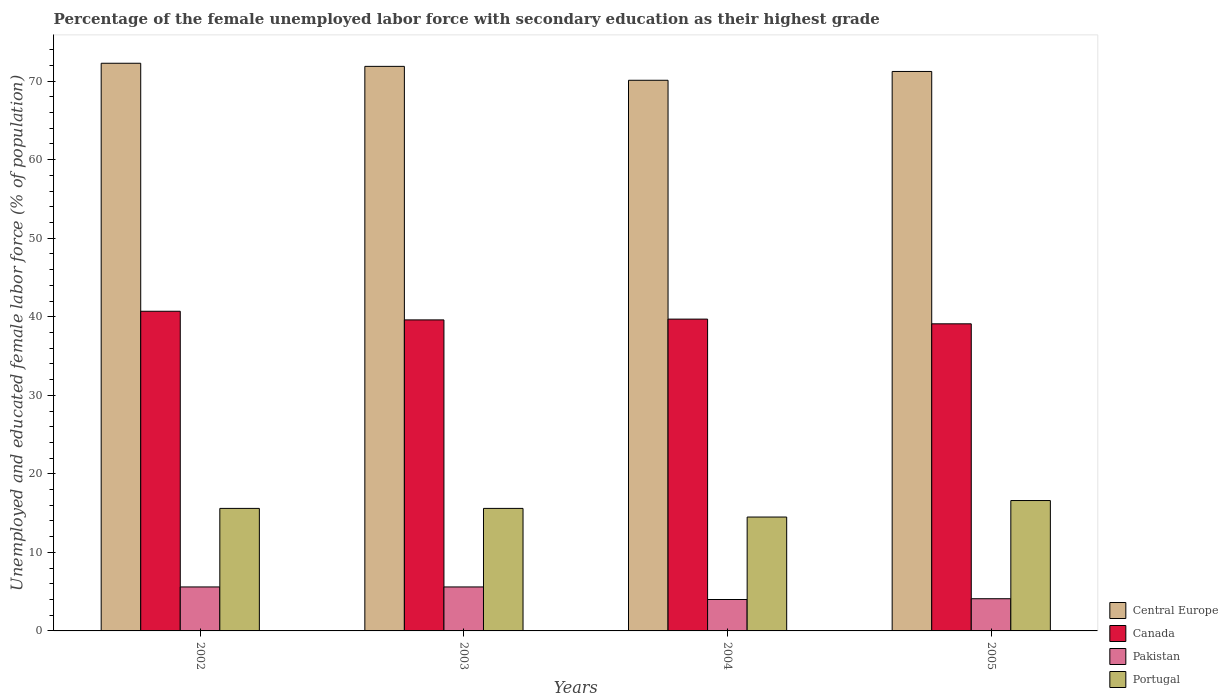How many groups of bars are there?
Make the answer very short. 4. Are the number of bars on each tick of the X-axis equal?
Offer a terse response. Yes. How many bars are there on the 1st tick from the left?
Give a very brief answer. 4. What is the label of the 3rd group of bars from the left?
Keep it short and to the point. 2004. What is the percentage of the unemployed female labor force with secondary education in Canada in 2005?
Ensure brevity in your answer.  39.1. Across all years, what is the maximum percentage of the unemployed female labor force with secondary education in Portugal?
Offer a terse response. 16.6. What is the total percentage of the unemployed female labor force with secondary education in Central Europe in the graph?
Provide a short and direct response. 285.49. What is the difference between the percentage of the unemployed female labor force with secondary education in Canada in 2003 and that in 2004?
Ensure brevity in your answer.  -0.1. What is the difference between the percentage of the unemployed female labor force with secondary education in Canada in 2005 and the percentage of the unemployed female labor force with secondary education in Central Europe in 2004?
Give a very brief answer. -31.01. What is the average percentage of the unemployed female labor force with secondary education in Portugal per year?
Provide a short and direct response. 15.58. In the year 2005, what is the difference between the percentage of the unemployed female labor force with secondary education in Central Europe and percentage of the unemployed female labor force with secondary education in Pakistan?
Give a very brief answer. 67.13. What is the ratio of the percentage of the unemployed female labor force with secondary education in Portugal in 2002 to that in 2005?
Keep it short and to the point. 0.94. What is the difference between the highest and the lowest percentage of the unemployed female labor force with secondary education in Central Europe?
Provide a short and direct response. 2.17. In how many years, is the percentage of the unemployed female labor force with secondary education in Pakistan greater than the average percentage of the unemployed female labor force with secondary education in Pakistan taken over all years?
Your response must be concise. 2. Is the sum of the percentage of the unemployed female labor force with secondary education in Canada in 2003 and 2005 greater than the maximum percentage of the unemployed female labor force with secondary education in Central Europe across all years?
Ensure brevity in your answer.  Yes. Is it the case that in every year, the sum of the percentage of the unemployed female labor force with secondary education in Canada and percentage of the unemployed female labor force with secondary education in Portugal is greater than the sum of percentage of the unemployed female labor force with secondary education in Pakistan and percentage of the unemployed female labor force with secondary education in Central Europe?
Ensure brevity in your answer.  Yes. What does the 1st bar from the left in 2005 represents?
Give a very brief answer. Central Europe. Is it the case that in every year, the sum of the percentage of the unemployed female labor force with secondary education in Pakistan and percentage of the unemployed female labor force with secondary education in Central Europe is greater than the percentage of the unemployed female labor force with secondary education in Portugal?
Ensure brevity in your answer.  Yes. How many bars are there?
Your answer should be compact. 16. Are all the bars in the graph horizontal?
Keep it short and to the point. No. How many years are there in the graph?
Keep it short and to the point. 4. What is the difference between two consecutive major ticks on the Y-axis?
Your answer should be very brief. 10. Are the values on the major ticks of Y-axis written in scientific E-notation?
Your response must be concise. No. Where does the legend appear in the graph?
Offer a very short reply. Bottom right. How are the legend labels stacked?
Your response must be concise. Vertical. What is the title of the graph?
Make the answer very short. Percentage of the female unemployed labor force with secondary education as their highest grade. Does "Japan" appear as one of the legend labels in the graph?
Your response must be concise. No. What is the label or title of the X-axis?
Provide a short and direct response. Years. What is the label or title of the Y-axis?
Keep it short and to the point. Unemployed and educated female labor force (% of population). What is the Unemployed and educated female labor force (% of population) of Central Europe in 2002?
Keep it short and to the point. 72.28. What is the Unemployed and educated female labor force (% of population) in Canada in 2002?
Your answer should be compact. 40.7. What is the Unemployed and educated female labor force (% of population) of Pakistan in 2002?
Offer a terse response. 5.6. What is the Unemployed and educated female labor force (% of population) in Portugal in 2002?
Make the answer very short. 15.6. What is the Unemployed and educated female labor force (% of population) of Central Europe in 2003?
Offer a very short reply. 71.88. What is the Unemployed and educated female labor force (% of population) in Canada in 2003?
Offer a very short reply. 39.6. What is the Unemployed and educated female labor force (% of population) of Pakistan in 2003?
Your response must be concise. 5.6. What is the Unemployed and educated female labor force (% of population) in Portugal in 2003?
Your answer should be compact. 15.6. What is the Unemployed and educated female labor force (% of population) of Central Europe in 2004?
Your answer should be compact. 70.11. What is the Unemployed and educated female labor force (% of population) in Canada in 2004?
Your response must be concise. 39.7. What is the Unemployed and educated female labor force (% of population) of Pakistan in 2004?
Your answer should be compact. 4. What is the Unemployed and educated female labor force (% of population) of Portugal in 2004?
Provide a short and direct response. 14.5. What is the Unemployed and educated female labor force (% of population) in Central Europe in 2005?
Provide a succinct answer. 71.23. What is the Unemployed and educated female labor force (% of population) in Canada in 2005?
Ensure brevity in your answer.  39.1. What is the Unemployed and educated female labor force (% of population) in Pakistan in 2005?
Your response must be concise. 4.1. What is the Unemployed and educated female labor force (% of population) of Portugal in 2005?
Keep it short and to the point. 16.6. Across all years, what is the maximum Unemployed and educated female labor force (% of population) in Central Europe?
Ensure brevity in your answer.  72.28. Across all years, what is the maximum Unemployed and educated female labor force (% of population) of Canada?
Offer a very short reply. 40.7. Across all years, what is the maximum Unemployed and educated female labor force (% of population) in Pakistan?
Keep it short and to the point. 5.6. Across all years, what is the maximum Unemployed and educated female labor force (% of population) in Portugal?
Provide a succinct answer. 16.6. Across all years, what is the minimum Unemployed and educated female labor force (% of population) in Central Europe?
Offer a terse response. 70.11. Across all years, what is the minimum Unemployed and educated female labor force (% of population) of Canada?
Keep it short and to the point. 39.1. What is the total Unemployed and educated female labor force (% of population) in Central Europe in the graph?
Provide a succinct answer. 285.49. What is the total Unemployed and educated female labor force (% of population) in Canada in the graph?
Make the answer very short. 159.1. What is the total Unemployed and educated female labor force (% of population) of Pakistan in the graph?
Provide a short and direct response. 19.3. What is the total Unemployed and educated female labor force (% of population) of Portugal in the graph?
Offer a terse response. 62.3. What is the difference between the Unemployed and educated female labor force (% of population) of Central Europe in 2002 and that in 2003?
Provide a short and direct response. 0.4. What is the difference between the Unemployed and educated female labor force (% of population) in Canada in 2002 and that in 2003?
Your answer should be very brief. 1.1. What is the difference between the Unemployed and educated female labor force (% of population) in Pakistan in 2002 and that in 2003?
Provide a short and direct response. 0. What is the difference between the Unemployed and educated female labor force (% of population) of Central Europe in 2002 and that in 2004?
Offer a very short reply. 2.17. What is the difference between the Unemployed and educated female labor force (% of population) in Central Europe in 2002 and that in 2005?
Your response must be concise. 1.04. What is the difference between the Unemployed and educated female labor force (% of population) in Pakistan in 2002 and that in 2005?
Offer a terse response. 1.5. What is the difference between the Unemployed and educated female labor force (% of population) of Central Europe in 2003 and that in 2004?
Keep it short and to the point. 1.77. What is the difference between the Unemployed and educated female labor force (% of population) of Canada in 2003 and that in 2004?
Provide a succinct answer. -0.1. What is the difference between the Unemployed and educated female labor force (% of population) in Pakistan in 2003 and that in 2004?
Your answer should be very brief. 1.6. What is the difference between the Unemployed and educated female labor force (% of population) in Central Europe in 2003 and that in 2005?
Your response must be concise. 0.65. What is the difference between the Unemployed and educated female labor force (% of population) of Pakistan in 2003 and that in 2005?
Your answer should be very brief. 1.5. What is the difference between the Unemployed and educated female labor force (% of population) of Portugal in 2003 and that in 2005?
Offer a very short reply. -1. What is the difference between the Unemployed and educated female labor force (% of population) in Central Europe in 2004 and that in 2005?
Ensure brevity in your answer.  -1.12. What is the difference between the Unemployed and educated female labor force (% of population) in Central Europe in 2002 and the Unemployed and educated female labor force (% of population) in Canada in 2003?
Your answer should be very brief. 32.68. What is the difference between the Unemployed and educated female labor force (% of population) of Central Europe in 2002 and the Unemployed and educated female labor force (% of population) of Pakistan in 2003?
Give a very brief answer. 66.68. What is the difference between the Unemployed and educated female labor force (% of population) of Central Europe in 2002 and the Unemployed and educated female labor force (% of population) of Portugal in 2003?
Offer a very short reply. 56.68. What is the difference between the Unemployed and educated female labor force (% of population) of Canada in 2002 and the Unemployed and educated female labor force (% of population) of Pakistan in 2003?
Make the answer very short. 35.1. What is the difference between the Unemployed and educated female labor force (% of population) of Canada in 2002 and the Unemployed and educated female labor force (% of population) of Portugal in 2003?
Your response must be concise. 25.1. What is the difference between the Unemployed and educated female labor force (% of population) of Central Europe in 2002 and the Unemployed and educated female labor force (% of population) of Canada in 2004?
Provide a short and direct response. 32.58. What is the difference between the Unemployed and educated female labor force (% of population) of Central Europe in 2002 and the Unemployed and educated female labor force (% of population) of Pakistan in 2004?
Offer a very short reply. 68.28. What is the difference between the Unemployed and educated female labor force (% of population) of Central Europe in 2002 and the Unemployed and educated female labor force (% of population) of Portugal in 2004?
Your answer should be compact. 57.78. What is the difference between the Unemployed and educated female labor force (% of population) in Canada in 2002 and the Unemployed and educated female labor force (% of population) in Pakistan in 2004?
Offer a very short reply. 36.7. What is the difference between the Unemployed and educated female labor force (% of population) in Canada in 2002 and the Unemployed and educated female labor force (% of population) in Portugal in 2004?
Provide a short and direct response. 26.2. What is the difference between the Unemployed and educated female labor force (% of population) of Pakistan in 2002 and the Unemployed and educated female labor force (% of population) of Portugal in 2004?
Your answer should be compact. -8.9. What is the difference between the Unemployed and educated female labor force (% of population) of Central Europe in 2002 and the Unemployed and educated female labor force (% of population) of Canada in 2005?
Offer a terse response. 33.18. What is the difference between the Unemployed and educated female labor force (% of population) of Central Europe in 2002 and the Unemployed and educated female labor force (% of population) of Pakistan in 2005?
Provide a succinct answer. 68.18. What is the difference between the Unemployed and educated female labor force (% of population) in Central Europe in 2002 and the Unemployed and educated female labor force (% of population) in Portugal in 2005?
Offer a terse response. 55.68. What is the difference between the Unemployed and educated female labor force (% of population) in Canada in 2002 and the Unemployed and educated female labor force (% of population) in Pakistan in 2005?
Provide a succinct answer. 36.6. What is the difference between the Unemployed and educated female labor force (% of population) of Canada in 2002 and the Unemployed and educated female labor force (% of population) of Portugal in 2005?
Ensure brevity in your answer.  24.1. What is the difference between the Unemployed and educated female labor force (% of population) in Pakistan in 2002 and the Unemployed and educated female labor force (% of population) in Portugal in 2005?
Provide a short and direct response. -11. What is the difference between the Unemployed and educated female labor force (% of population) in Central Europe in 2003 and the Unemployed and educated female labor force (% of population) in Canada in 2004?
Your response must be concise. 32.18. What is the difference between the Unemployed and educated female labor force (% of population) in Central Europe in 2003 and the Unemployed and educated female labor force (% of population) in Pakistan in 2004?
Give a very brief answer. 67.88. What is the difference between the Unemployed and educated female labor force (% of population) of Central Europe in 2003 and the Unemployed and educated female labor force (% of population) of Portugal in 2004?
Ensure brevity in your answer.  57.38. What is the difference between the Unemployed and educated female labor force (% of population) of Canada in 2003 and the Unemployed and educated female labor force (% of population) of Pakistan in 2004?
Make the answer very short. 35.6. What is the difference between the Unemployed and educated female labor force (% of population) of Canada in 2003 and the Unemployed and educated female labor force (% of population) of Portugal in 2004?
Your answer should be very brief. 25.1. What is the difference between the Unemployed and educated female labor force (% of population) in Central Europe in 2003 and the Unemployed and educated female labor force (% of population) in Canada in 2005?
Give a very brief answer. 32.78. What is the difference between the Unemployed and educated female labor force (% of population) of Central Europe in 2003 and the Unemployed and educated female labor force (% of population) of Pakistan in 2005?
Keep it short and to the point. 67.78. What is the difference between the Unemployed and educated female labor force (% of population) of Central Europe in 2003 and the Unemployed and educated female labor force (% of population) of Portugal in 2005?
Your answer should be compact. 55.28. What is the difference between the Unemployed and educated female labor force (% of population) of Canada in 2003 and the Unemployed and educated female labor force (% of population) of Pakistan in 2005?
Make the answer very short. 35.5. What is the difference between the Unemployed and educated female labor force (% of population) of Central Europe in 2004 and the Unemployed and educated female labor force (% of population) of Canada in 2005?
Ensure brevity in your answer.  31.01. What is the difference between the Unemployed and educated female labor force (% of population) in Central Europe in 2004 and the Unemployed and educated female labor force (% of population) in Pakistan in 2005?
Offer a terse response. 66.01. What is the difference between the Unemployed and educated female labor force (% of population) of Central Europe in 2004 and the Unemployed and educated female labor force (% of population) of Portugal in 2005?
Your answer should be very brief. 53.51. What is the difference between the Unemployed and educated female labor force (% of population) in Canada in 2004 and the Unemployed and educated female labor force (% of population) in Pakistan in 2005?
Offer a terse response. 35.6. What is the difference between the Unemployed and educated female labor force (% of population) in Canada in 2004 and the Unemployed and educated female labor force (% of population) in Portugal in 2005?
Offer a terse response. 23.1. What is the difference between the Unemployed and educated female labor force (% of population) of Pakistan in 2004 and the Unemployed and educated female labor force (% of population) of Portugal in 2005?
Offer a very short reply. -12.6. What is the average Unemployed and educated female labor force (% of population) in Central Europe per year?
Make the answer very short. 71.37. What is the average Unemployed and educated female labor force (% of population) in Canada per year?
Your answer should be very brief. 39.77. What is the average Unemployed and educated female labor force (% of population) of Pakistan per year?
Provide a succinct answer. 4.83. What is the average Unemployed and educated female labor force (% of population) of Portugal per year?
Provide a short and direct response. 15.57. In the year 2002, what is the difference between the Unemployed and educated female labor force (% of population) in Central Europe and Unemployed and educated female labor force (% of population) in Canada?
Provide a short and direct response. 31.58. In the year 2002, what is the difference between the Unemployed and educated female labor force (% of population) of Central Europe and Unemployed and educated female labor force (% of population) of Pakistan?
Make the answer very short. 66.68. In the year 2002, what is the difference between the Unemployed and educated female labor force (% of population) of Central Europe and Unemployed and educated female labor force (% of population) of Portugal?
Your answer should be very brief. 56.68. In the year 2002, what is the difference between the Unemployed and educated female labor force (% of population) in Canada and Unemployed and educated female labor force (% of population) in Pakistan?
Keep it short and to the point. 35.1. In the year 2002, what is the difference between the Unemployed and educated female labor force (% of population) of Canada and Unemployed and educated female labor force (% of population) of Portugal?
Ensure brevity in your answer.  25.1. In the year 2002, what is the difference between the Unemployed and educated female labor force (% of population) in Pakistan and Unemployed and educated female labor force (% of population) in Portugal?
Give a very brief answer. -10. In the year 2003, what is the difference between the Unemployed and educated female labor force (% of population) of Central Europe and Unemployed and educated female labor force (% of population) of Canada?
Keep it short and to the point. 32.28. In the year 2003, what is the difference between the Unemployed and educated female labor force (% of population) in Central Europe and Unemployed and educated female labor force (% of population) in Pakistan?
Your answer should be very brief. 66.28. In the year 2003, what is the difference between the Unemployed and educated female labor force (% of population) in Central Europe and Unemployed and educated female labor force (% of population) in Portugal?
Your answer should be compact. 56.28. In the year 2003, what is the difference between the Unemployed and educated female labor force (% of population) in Canada and Unemployed and educated female labor force (% of population) in Portugal?
Provide a short and direct response. 24. In the year 2003, what is the difference between the Unemployed and educated female labor force (% of population) of Pakistan and Unemployed and educated female labor force (% of population) of Portugal?
Your response must be concise. -10. In the year 2004, what is the difference between the Unemployed and educated female labor force (% of population) of Central Europe and Unemployed and educated female labor force (% of population) of Canada?
Provide a succinct answer. 30.41. In the year 2004, what is the difference between the Unemployed and educated female labor force (% of population) in Central Europe and Unemployed and educated female labor force (% of population) in Pakistan?
Keep it short and to the point. 66.11. In the year 2004, what is the difference between the Unemployed and educated female labor force (% of population) in Central Europe and Unemployed and educated female labor force (% of population) in Portugal?
Provide a short and direct response. 55.61. In the year 2004, what is the difference between the Unemployed and educated female labor force (% of population) of Canada and Unemployed and educated female labor force (% of population) of Pakistan?
Make the answer very short. 35.7. In the year 2004, what is the difference between the Unemployed and educated female labor force (% of population) of Canada and Unemployed and educated female labor force (% of population) of Portugal?
Provide a succinct answer. 25.2. In the year 2005, what is the difference between the Unemployed and educated female labor force (% of population) of Central Europe and Unemployed and educated female labor force (% of population) of Canada?
Ensure brevity in your answer.  32.13. In the year 2005, what is the difference between the Unemployed and educated female labor force (% of population) of Central Europe and Unemployed and educated female labor force (% of population) of Pakistan?
Offer a very short reply. 67.13. In the year 2005, what is the difference between the Unemployed and educated female labor force (% of population) of Central Europe and Unemployed and educated female labor force (% of population) of Portugal?
Provide a succinct answer. 54.63. In the year 2005, what is the difference between the Unemployed and educated female labor force (% of population) of Canada and Unemployed and educated female labor force (% of population) of Pakistan?
Your response must be concise. 35. In the year 2005, what is the difference between the Unemployed and educated female labor force (% of population) of Pakistan and Unemployed and educated female labor force (% of population) of Portugal?
Your answer should be very brief. -12.5. What is the ratio of the Unemployed and educated female labor force (% of population) in Central Europe in 2002 to that in 2003?
Your answer should be very brief. 1.01. What is the ratio of the Unemployed and educated female labor force (% of population) of Canada in 2002 to that in 2003?
Make the answer very short. 1.03. What is the ratio of the Unemployed and educated female labor force (% of population) in Pakistan in 2002 to that in 2003?
Give a very brief answer. 1. What is the ratio of the Unemployed and educated female labor force (% of population) of Portugal in 2002 to that in 2003?
Give a very brief answer. 1. What is the ratio of the Unemployed and educated female labor force (% of population) of Central Europe in 2002 to that in 2004?
Give a very brief answer. 1.03. What is the ratio of the Unemployed and educated female labor force (% of population) of Canada in 2002 to that in 2004?
Offer a very short reply. 1.03. What is the ratio of the Unemployed and educated female labor force (% of population) in Pakistan in 2002 to that in 2004?
Your answer should be very brief. 1.4. What is the ratio of the Unemployed and educated female labor force (% of population) of Portugal in 2002 to that in 2004?
Provide a short and direct response. 1.08. What is the ratio of the Unemployed and educated female labor force (% of population) of Central Europe in 2002 to that in 2005?
Keep it short and to the point. 1.01. What is the ratio of the Unemployed and educated female labor force (% of population) in Canada in 2002 to that in 2005?
Provide a short and direct response. 1.04. What is the ratio of the Unemployed and educated female labor force (% of population) of Pakistan in 2002 to that in 2005?
Offer a terse response. 1.37. What is the ratio of the Unemployed and educated female labor force (% of population) in Portugal in 2002 to that in 2005?
Your answer should be very brief. 0.94. What is the ratio of the Unemployed and educated female labor force (% of population) in Central Europe in 2003 to that in 2004?
Your answer should be compact. 1.03. What is the ratio of the Unemployed and educated female labor force (% of population) of Pakistan in 2003 to that in 2004?
Provide a succinct answer. 1.4. What is the ratio of the Unemployed and educated female labor force (% of population) in Portugal in 2003 to that in 2004?
Your response must be concise. 1.08. What is the ratio of the Unemployed and educated female labor force (% of population) in Central Europe in 2003 to that in 2005?
Keep it short and to the point. 1.01. What is the ratio of the Unemployed and educated female labor force (% of population) of Canada in 2003 to that in 2005?
Your response must be concise. 1.01. What is the ratio of the Unemployed and educated female labor force (% of population) of Pakistan in 2003 to that in 2005?
Keep it short and to the point. 1.37. What is the ratio of the Unemployed and educated female labor force (% of population) in Portugal in 2003 to that in 2005?
Make the answer very short. 0.94. What is the ratio of the Unemployed and educated female labor force (% of population) in Central Europe in 2004 to that in 2005?
Give a very brief answer. 0.98. What is the ratio of the Unemployed and educated female labor force (% of population) of Canada in 2004 to that in 2005?
Give a very brief answer. 1.02. What is the ratio of the Unemployed and educated female labor force (% of population) in Pakistan in 2004 to that in 2005?
Provide a short and direct response. 0.98. What is the ratio of the Unemployed and educated female labor force (% of population) of Portugal in 2004 to that in 2005?
Make the answer very short. 0.87. What is the difference between the highest and the second highest Unemployed and educated female labor force (% of population) of Central Europe?
Your answer should be compact. 0.4. What is the difference between the highest and the second highest Unemployed and educated female labor force (% of population) of Canada?
Your response must be concise. 1. What is the difference between the highest and the second highest Unemployed and educated female labor force (% of population) of Pakistan?
Make the answer very short. 0. What is the difference between the highest and the lowest Unemployed and educated female labor force (% of population) in Central Europe?
Keep it short and to the point. 2.17. What is the difference between the highest and the lowest Unemployed and educated female labor force (% of population) of Canada?
Offer a very short reply. 1.6. 